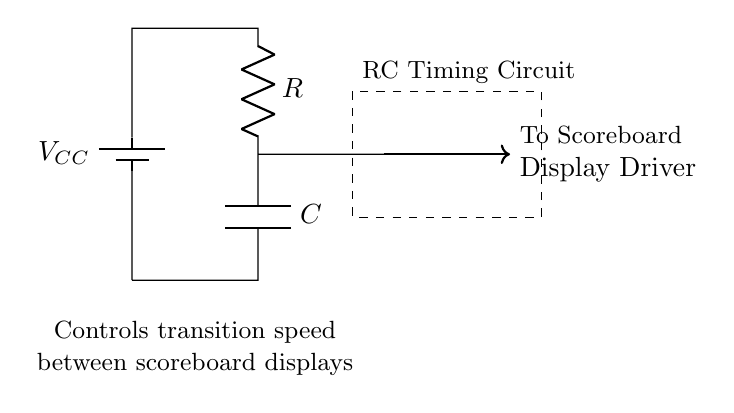What is the component type associated with the circular shape in the circuit? The circular shape identifies a capacitor, which is typically represented as two parallel plates or lines in circuit diagrams. Here, the label notes it is a Capacitor.
Answer: Capacitor What does the symbol "R" represent in the circuit? The letter "R" designates a resistor in the circuit diagram, which is used to limit current flow or divide voltages.
Answer: Resistor What is the function of the capacitor in this circuit? The capacitor stores electrical energy and releases it, controlling the timing of transitions between different scoreboard displays, effectively functioning in timing applications.
Answer: Timing What voltage is the battery supplying? The label "V sub CC" indicates the voltage source in the circuit, which is the supply voltage for the RC timing circuit. From context, it is often a positive voltage.
Answer: V sub CC How does the resistor value affect the timing? The resistance value determines how quickly the capacitor charges and discharges, influencing the transition speed between the different states of the scoreboard display. A higher resistance slows down the timing.
Answer: Yes, resistor value affects timing What does the thick arrow indicate in the circuit? The thick arrow illustrates the direction of current flow from the RC timing circuit to the scoreboard display driver, showing the active output.
Answer: Current direction What would happen if the capacitor were replaced with a larger value capacitor? A larger capacitor would increase the timing interval, which would make the transitions between scoreboard displays slower, as it takes longer to charge and discharge.
Answer: Slower transitions 